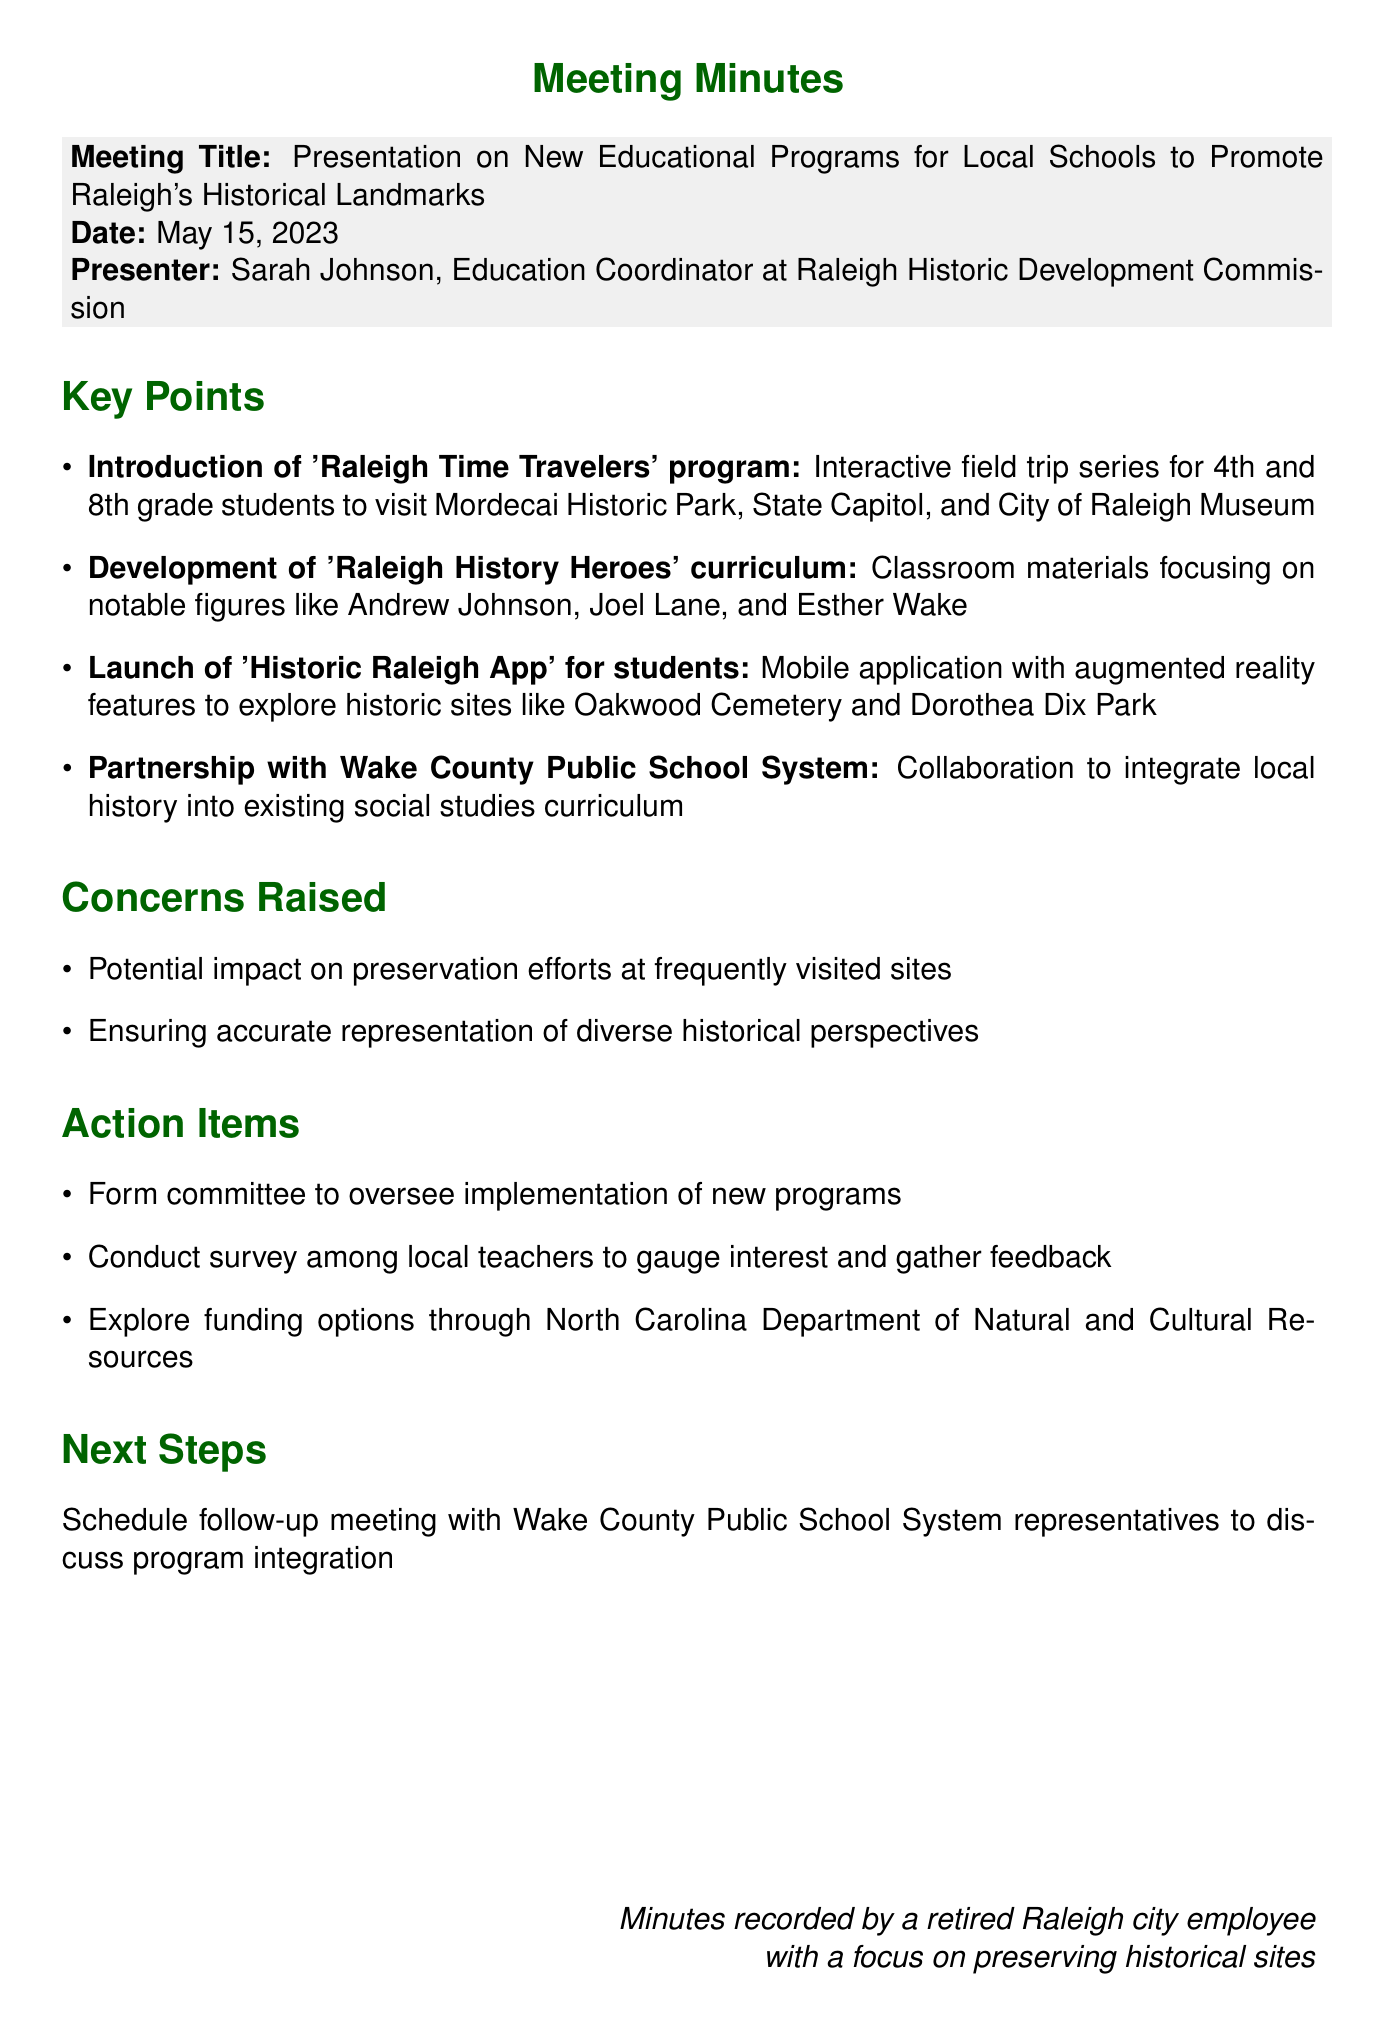What is the date of the meeting? The date is specified in the document.
Answer: May 15, 2023 Who presented the educational programs? The presenter's name and title are mentioned in the document.
Answer: Sarah Johnson, Education Coordinator at Raleigh Historic Development Commission What is the name of the interactive field trip program introduced? The document specifies the title of the program.
Answer: Raleigh Time Travelers What is one of the concerns raised during the meeting? The document lists concerns raised in the meeting.
Answer: Potential impact on preservation efforts at frequently visited sites What are the next steps outlined in the document? The next steps are identified in the meeting minutes.
Answer: Schedule follow-up meeting with Wake County Public School System representatives to discuss program integration How many key points are listed in the document? The document includes a list of key points discussed.
Answer: Four What is one of the notable figures mentioned in the curriculum? The document includes notable figures covered in the curriculum.
Answer: Andrew Johnson What action item includes gathering feedback? The action items specify actions to be taken.
Answer: Conduct survey among local teachers to gauge interest and gather feedback What type of mobile application was launched? The document describes the nature of the application.
Answer: Historic Raleigh App 